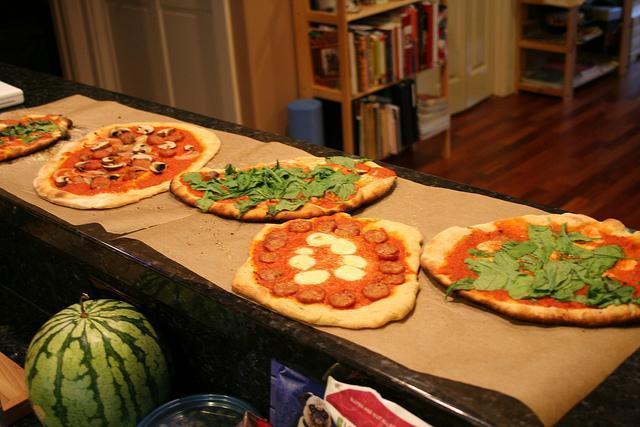How many dining tables can be seen?
Give a very brief answer. 1. How many pizzas are visible?
Give a very brief answer. 5. 